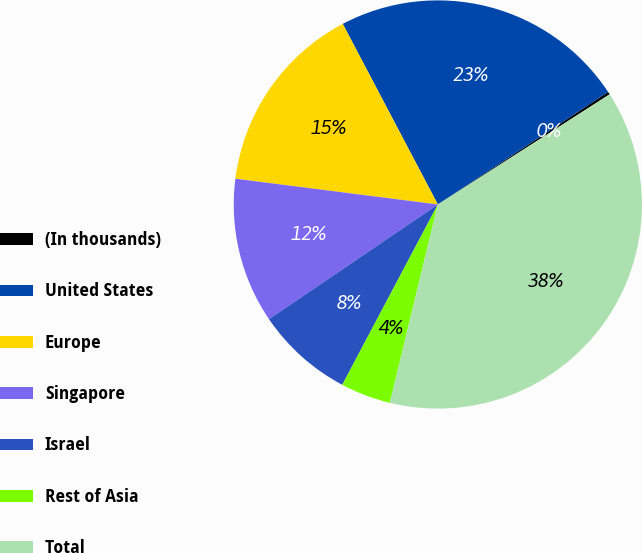<chart> <loc_0><loc_0><loc_500><loc_500><pie_chart><fcel>(In thousands)<fcel>United States<fcel>Europe<fcel>Singapore<fcel>Israel<fcel>Rest of Asia<fcel>Total<nl><fcel>0.22%<fcel>23.42%<fcel>15.27%<fcel>11.51%<fcel>7.75%<fcel>3.98%<fcel>37.85%<nl></chart> 